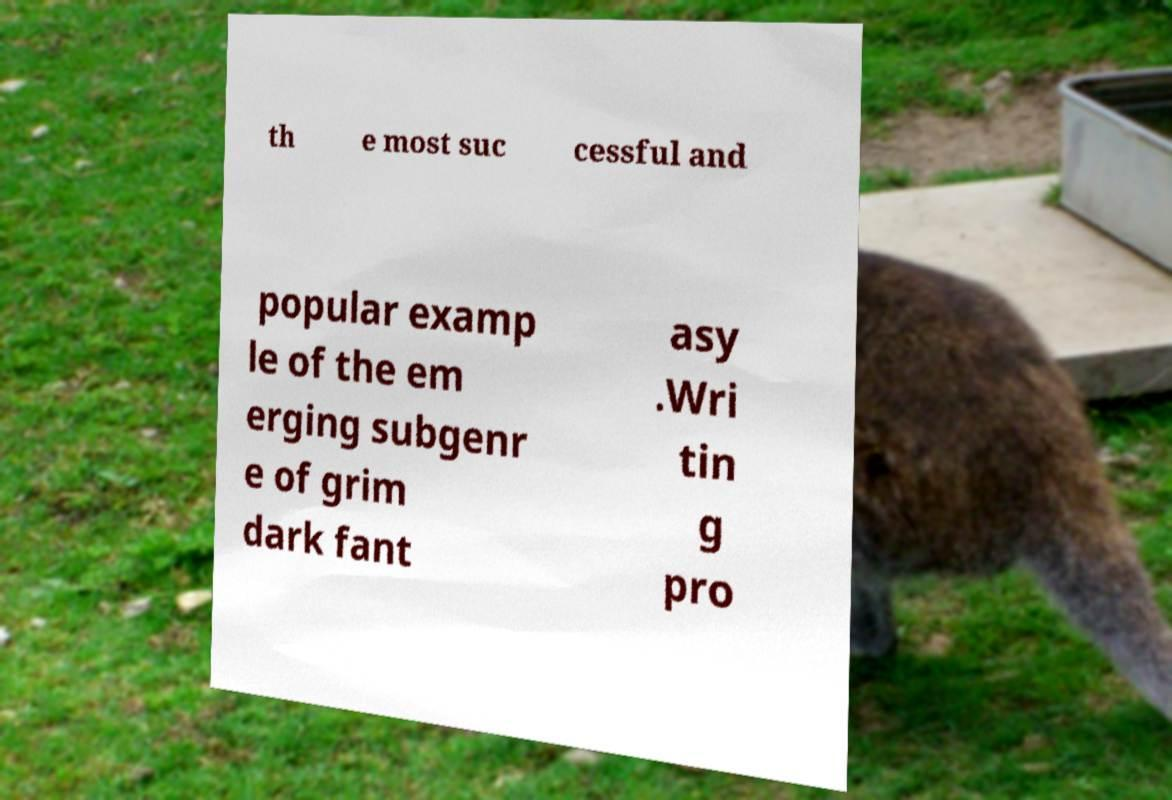There's text embedded in this image that I need extracted. Can you transcribe it verbatim? th e most suc cessful and popular examp le of the em erging subgenr e of grim dark fant asy .Wri tin g pro 